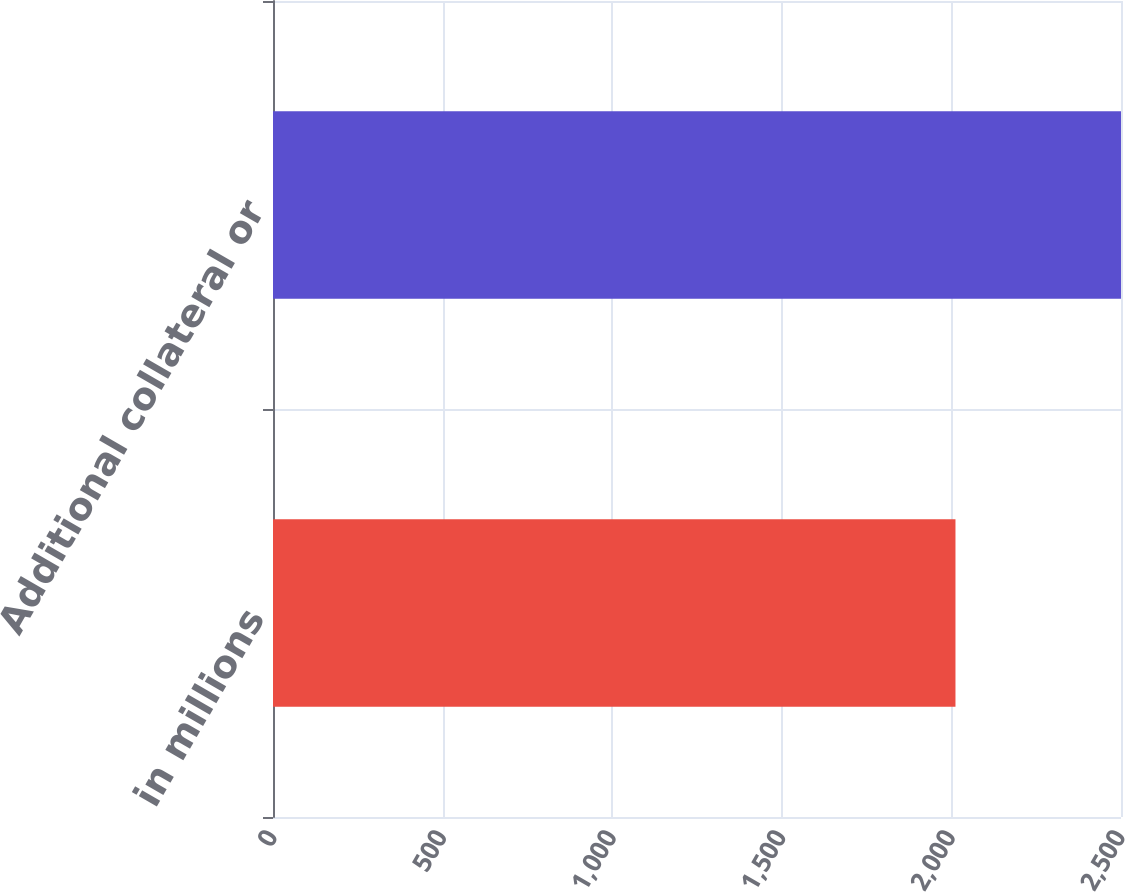Convert chart. <chart><loc_0><loc_0><loc_500><loc_500><bar_chart><fcel>in millions<fcel>Additional collateral or<nl><fcel>2012<fcel>2500<nl></chart> 